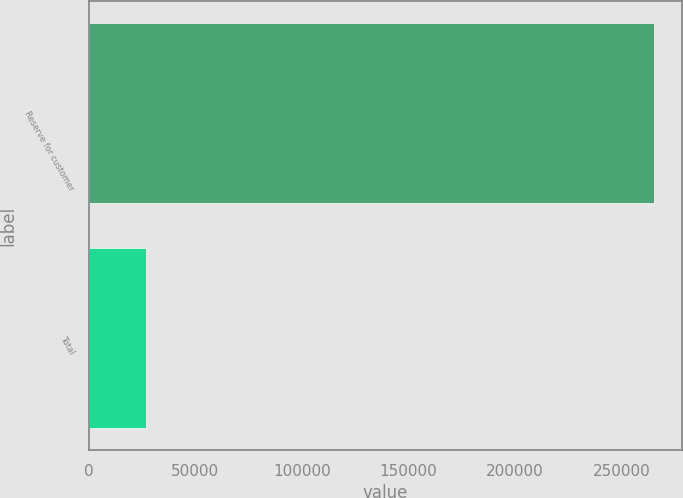Convert chart to OTSL. <chart><loc_0><loc_0><loc_500><loc_500><bar_chart><fcel>Reserve for customer<fcel>Total<nl><fcel>265262<fcel>27005<nl></chart> 